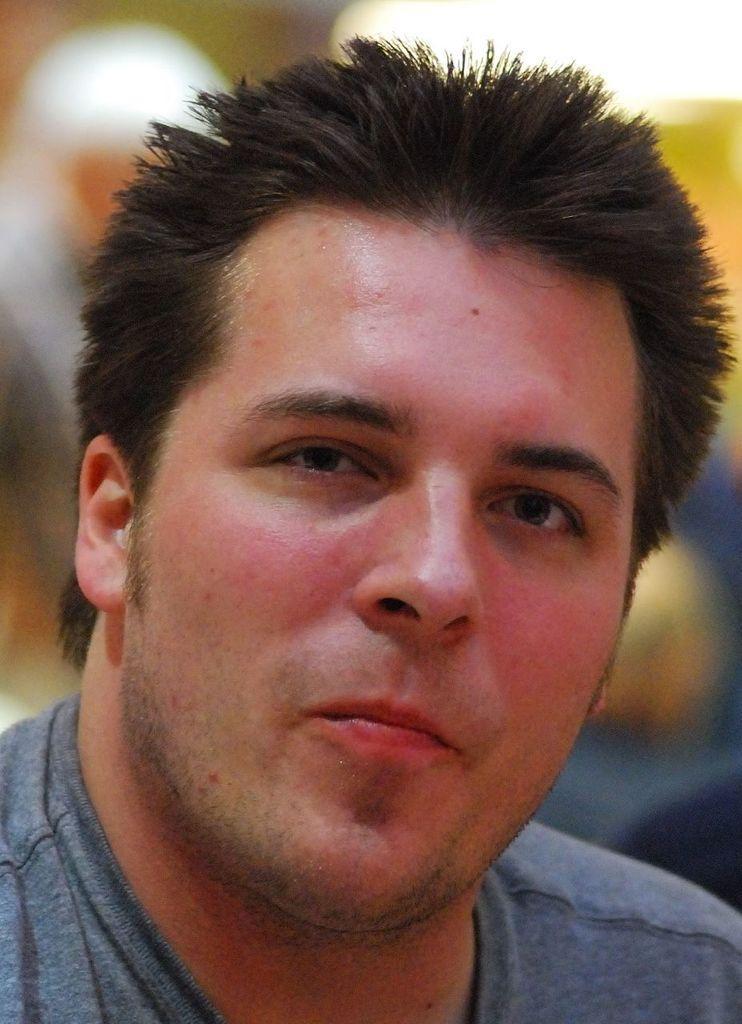Could you give a brief overview of what you see in this image? In the center of the image there is a person wearing a t-shirt. 